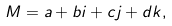Convert formula to latex. <formula><loc_0><loc_0><loc_500><loc_500>M = a + b i + c j + d k ,</formula> 